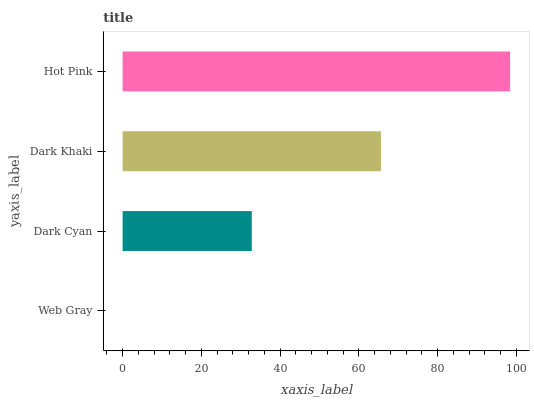Is Web Gray the minimum?
Answer yes or no. Yes. Is Hot Pink the maximum?
Answer yes or no. Yes. Is Dark Cyan the minimum?
Answer yes or no. No. Is Dark Cyan the maximum?
Answer yes or no. No. Is Dark Cyan greater than Web Gray?
Answer yes or no. Yes. Is Web Gray less than Dark Cyan?
Answer yes or no. Yes. Is Web Gray greater than Dark Cyan?
Answer yes or no. No. Is Dark Cyan less than Web Gray?
Answer yes or no. No. Is Dark Khaki the high median?
Answer yes or no. Yes. Is Dark Cyan the low median?
Answer yes or no. Yes. Is Hot Pink the high median?
Answer yes or no. No. Is Dark Khaki the low median?
Answer yes or no. No. 